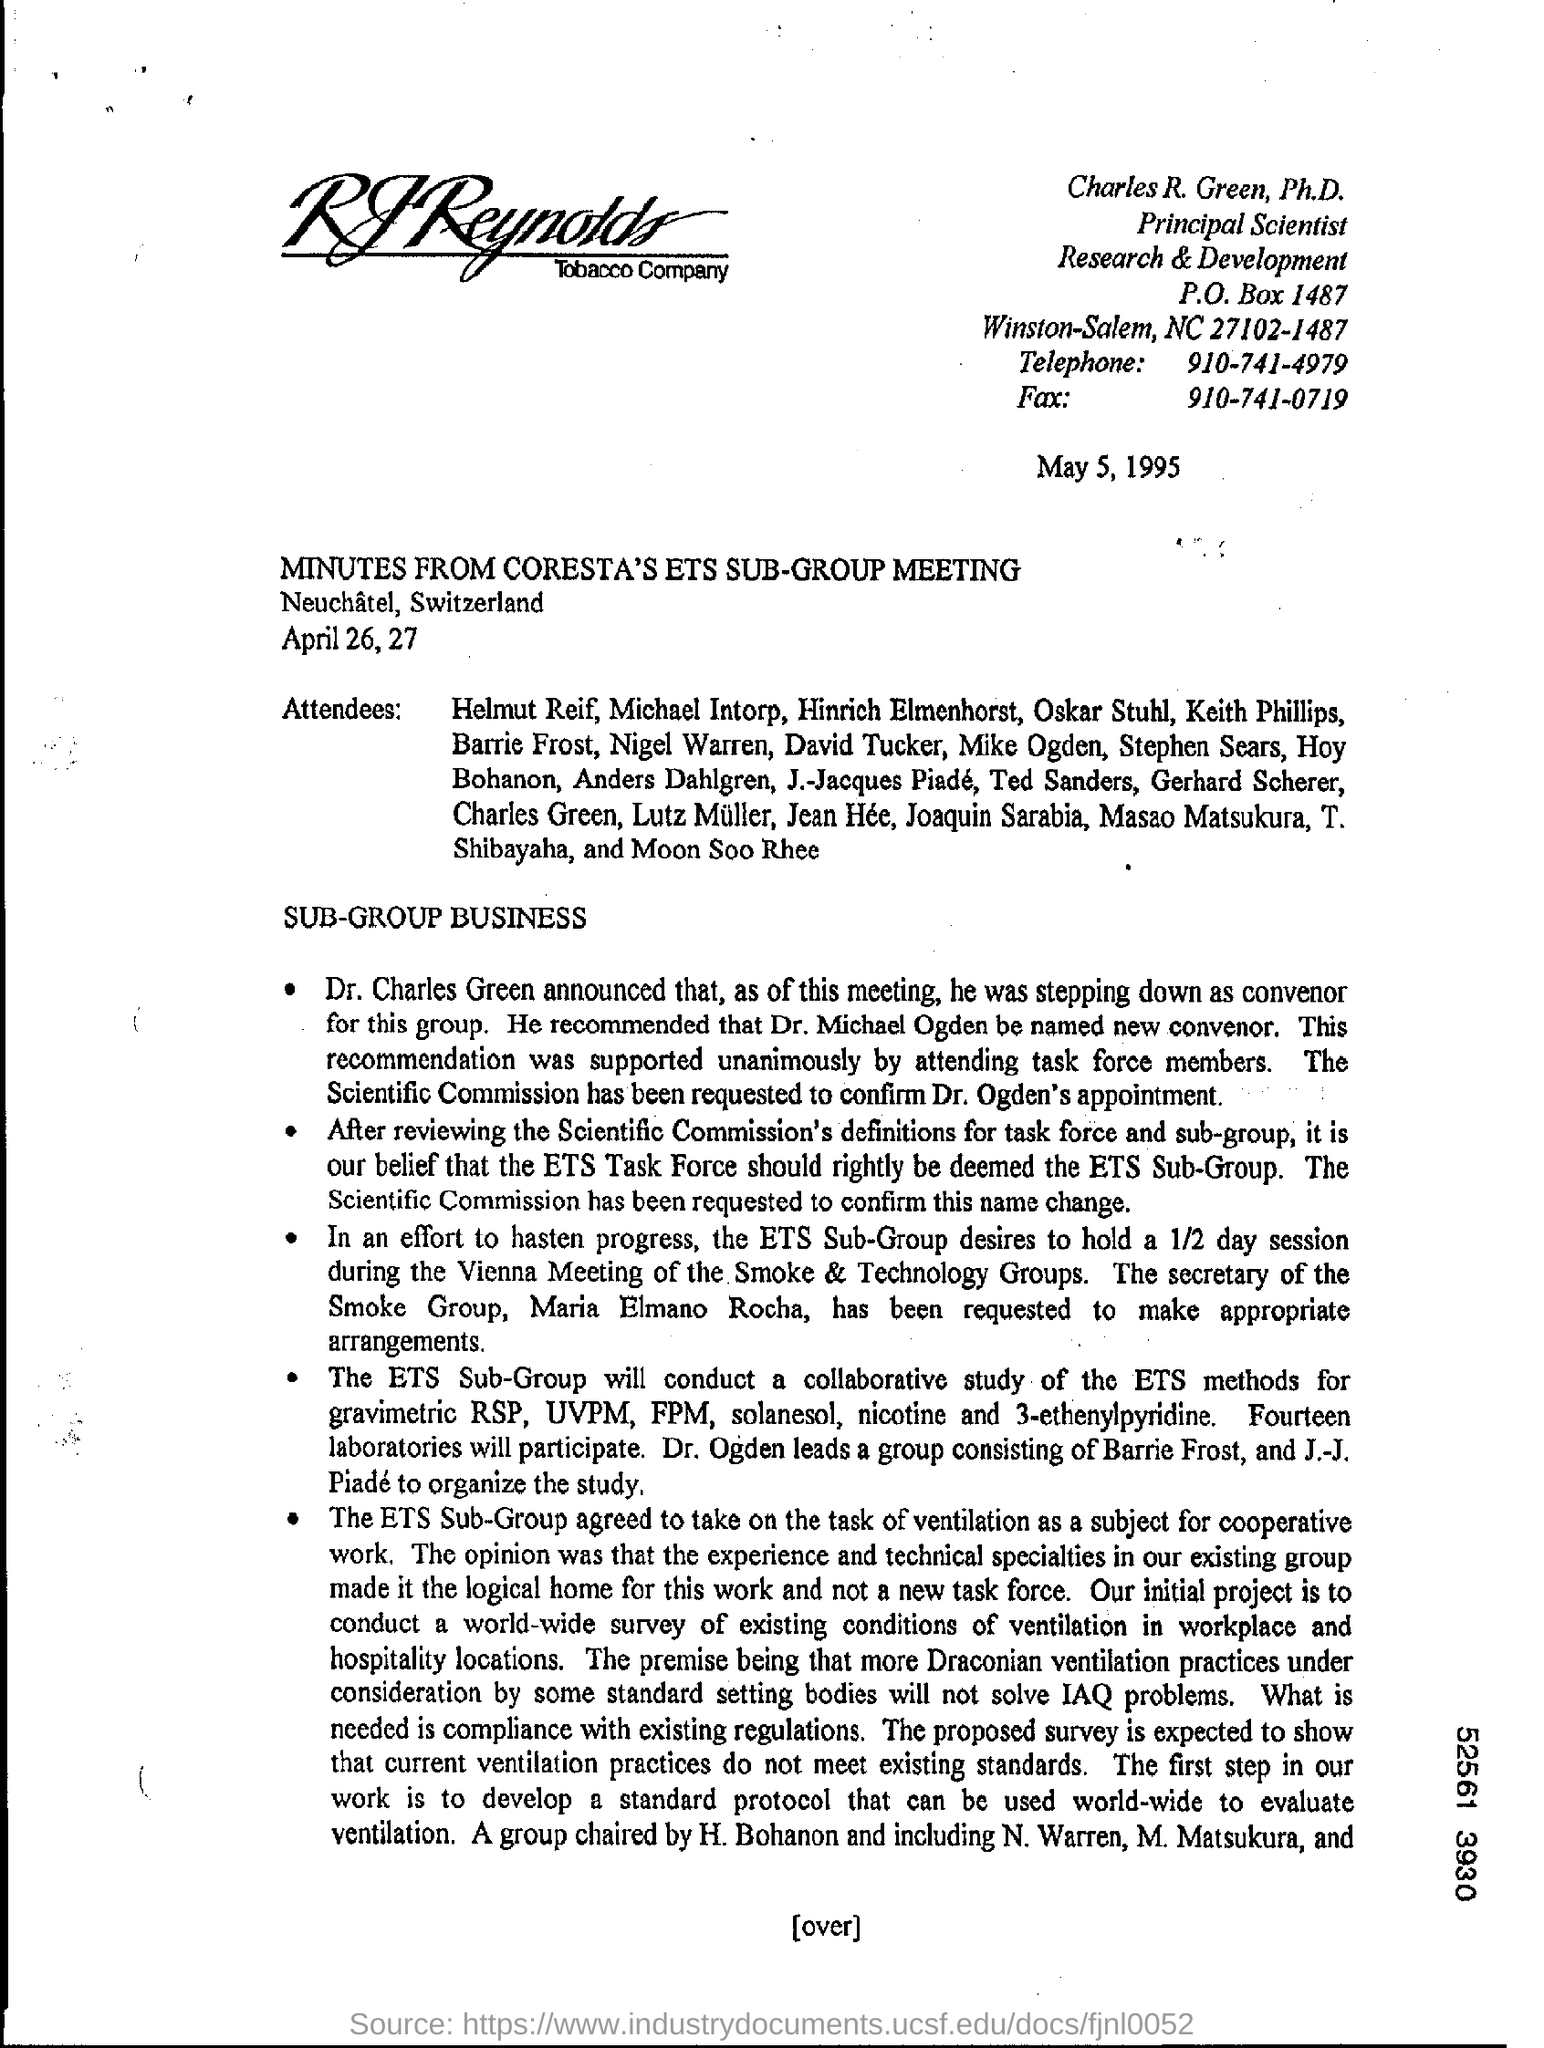What is the p.o box number?
Your answer should be compact. 1487. What is the telephone number?
Keep it short and to the point. 910-741-4979. What is the fax number?
Ensure brevity in your answer.  910-741-0719. 